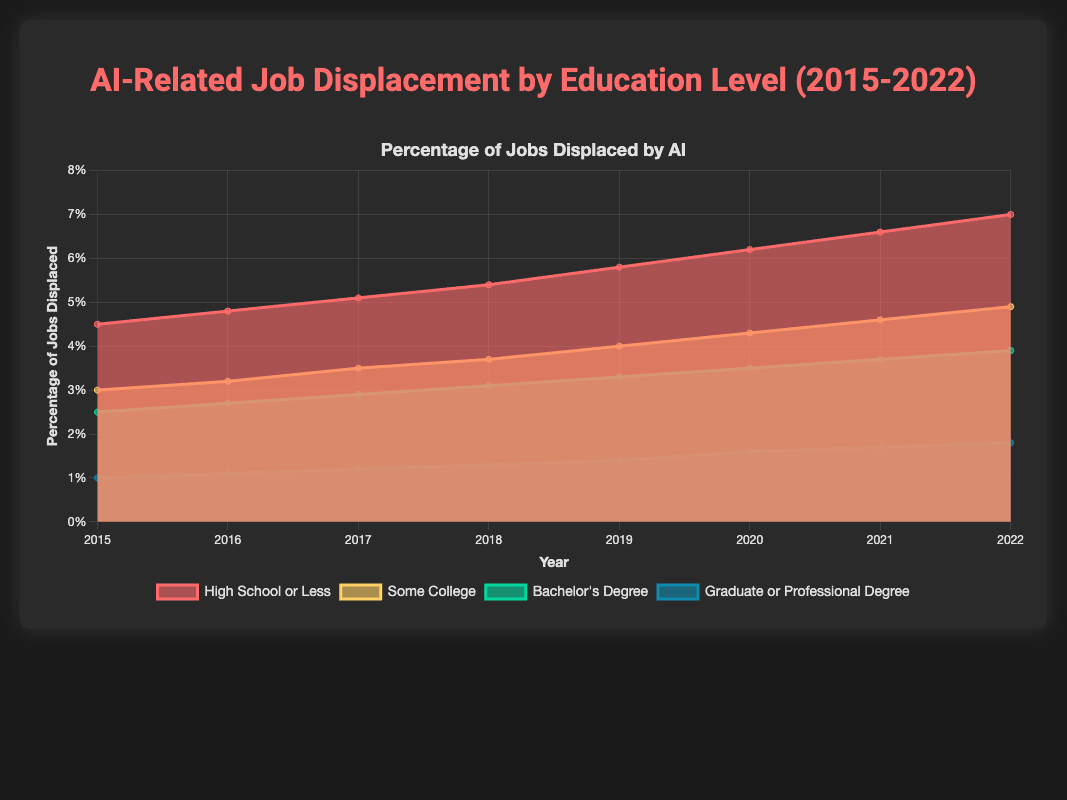what is shown by the Y-axis? The Y-axis shows the percentage of jobs displaced by AI.
Answer: percentage of jobs displaced How many educational attainment levels are represented in the chart? There are four educational attainment levels represented: High School or Less, Some College, Bachelor's Degree, and Graduate or Professional Degree.
Answer: four Which educational attainment level had the lowest percentage of job displacement in 2022? Look at the data for 2022. The "Graduate or Professional Degree" has the lowest percentage of job displacement at 1.8%.
Answer: Graduate or Professional Degree How did the job displacement percentage for "Some College" change from 2019 to 2022? In 2019, the percentage was 4.0%. In 2022, it was 4.9%. The change is 4.9% - 4.0% = 0.9%.
Answer: increased by 0.9% What is the average job displacement percentage for "Bachelor's Degree" from 2015 to 2022? Sum the percentages for each year for "Bachelor's Degree" and divide by the number of years: (2.5 + 2.7 + 2.9 + 3.1 + 3.3 + 3.5 + 3.7 + 3.9) / 8 = 3.2%.
Answer: 3.2% Which year saw the highest overall percentage of job displacement for "High School or Less"? Look at the data points for "High School or Less" each year. The highest value is 7.0% in 2022.
Answer: 2022 Compare the percentage increase in job displacement for "High School or Less" and "Graduate or Professional Degree" from 2015 to 2022. "High School or Less" increased from 4.5% to 7.0% (7.0% - 4.5% = 2.5%). "Graduate or Professional Degree" increased from 1.0% to 1.8% (1.8% - 1.0% = 0.8%).
Answer: High School or Less had a higher increase How did the job displacement trend for "Graduate or Professional Degree" compare to "Some College" over the period from 2015 to 2022? Both trends show a steady increase over the period. "Some College" started at 3.0% and ended at 4.9%, whereas "Graduate or Professional Degree" started at 1.0% and ended at 1.8%. "Some College" had a more significant increase.
Answer: Some College had a more significant increase What can be inferred about the overall trend of job displacement due to AI across different educational levels from 2015 to 2022? All educational levels show an increasing trend in job displacement due to AI, with those having a "High School or Less" education consistently experiencing the highest displacement.
Answer: Increasing trend across all levels 